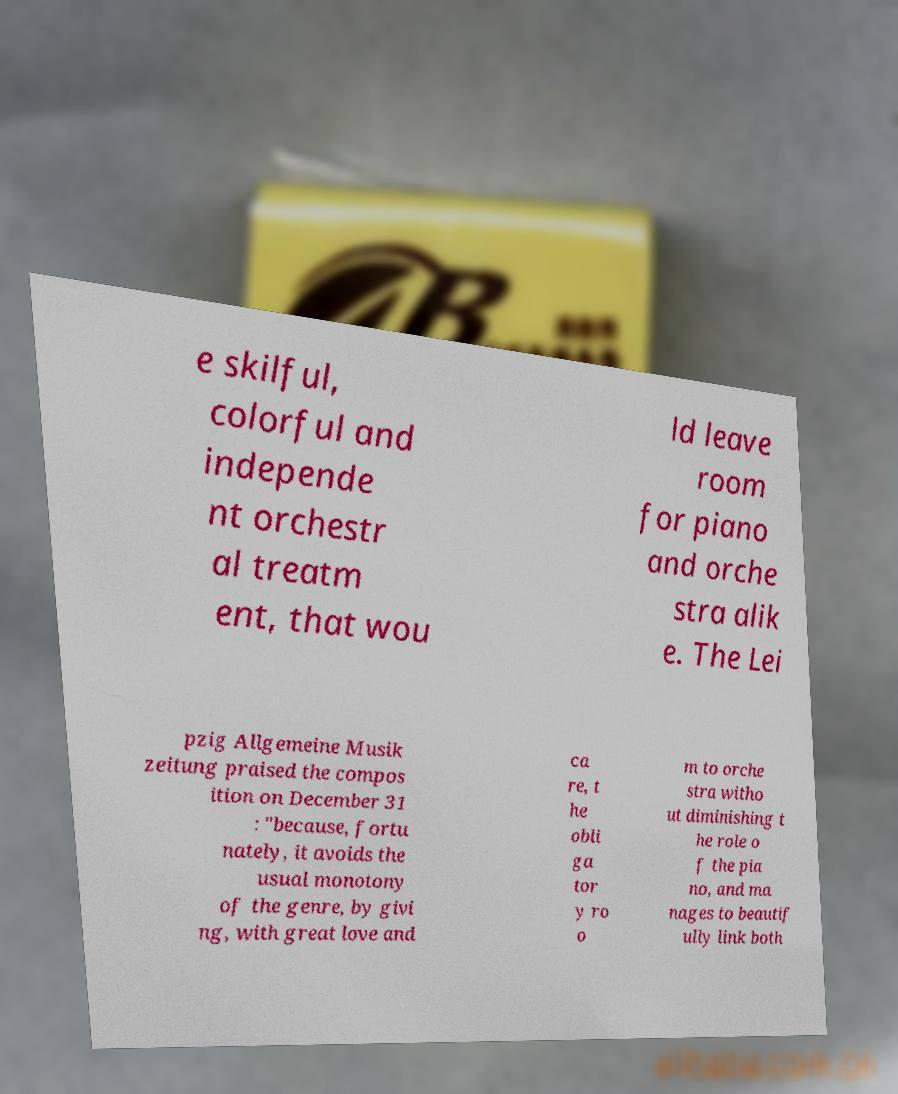There's text embedded in this image that I need extracted. Can you transcribe it verbatim? e skilful, colorful and independe nt orchestr al treatm ent, that wou ld leave room for piano and orche stra alik e. The Lei pzig Allgemeine Musik zeitung praised the compos ition on December 31 : "because, fortu nately, it avoids the usual monotony of the genre, by givi ng, with great love and ca re, t he obli ga tor y ro o m to orche stra witho ut diminishing t he role o f the pia no, and ma nages to beautif ully link both 